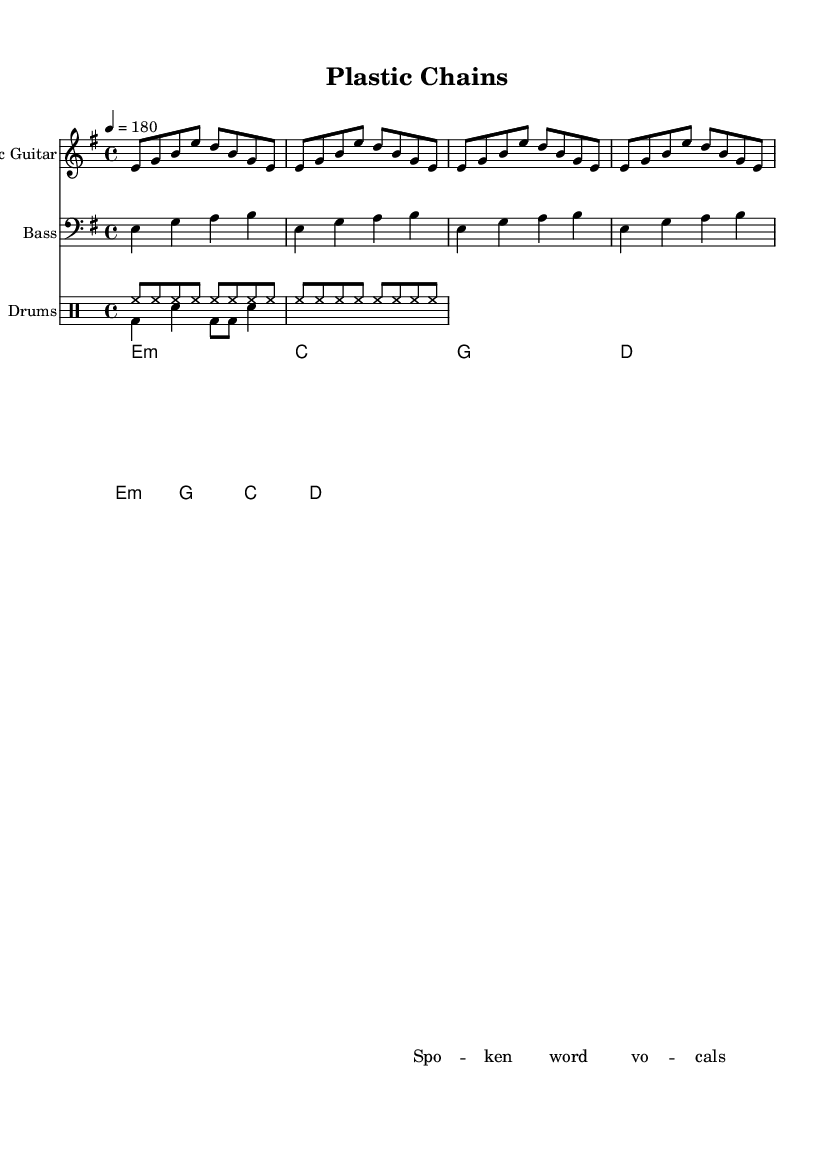What is the key signature of this music? The key signature is E minor, which has one sharp (F#). This can be determined by looking at the key signature section at the beginning of the sheet music.
Answer: E minor What is the time signature of this piece? The time signature is 4/4, which indicates that there are four beats in each measure, and a quarter note receives one beat. This information is explicitly stated in the time signature section of the sheet music.
Answer: 4/4 What is the tempo marking of the piece? The tempo marking is 180 beats per minute, which indicates the speed at which the piece should be played. This can be found next to the tempo indication in the sheet music.
Answer: 180 How many measures are there in the guitar riff? The guitar riff consists of 2 measures, as indicated by the notation and the repeat section at the beginning of the riff. Counting the given notation, there are two full sequences shown.
Answer: 2 What style of music is this composition primarily associated with? This composition is primarily associated with punk, which can be inferred from the fast-paced tempo and the use of a spoken word style in the lyrics, aligning with punk's typical characteristics.
Answer: Punk Which instruments are featured in this composition? The instruments featured are Electric Guitar, Bass, and Drums. This can be seen in the staff titles and the parts designated in the score.
Answer: Electric Guitar, Bass, Drums What is the structure, in terms of voice, of the lyrics? The lyrics structure indicates a spoken style with a repetition of "Spo -- ken word vo -- cals," which fits the narrative emphasis typical of fast-paced punk poetry. This can be found in the lyrics section of the sheet music.
Answer: Spoken word 